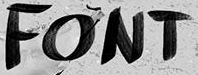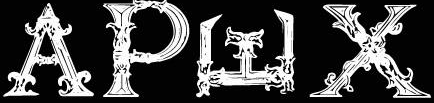What text is displayed in these images sequentially, separated by a semicolon? FONT; APWX 